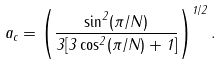<formula> <loc_0><loc_0><loc_500><loc_500>a _ { c } = \left ( \frac { \sin ^ { 2 } ( \pi / { N } ) } { 3 [ 3 \cos ^ { 2 } ( \pi / { N } ) + 1 ] } \right ) ^ { 1 / 2 } .</formula> 